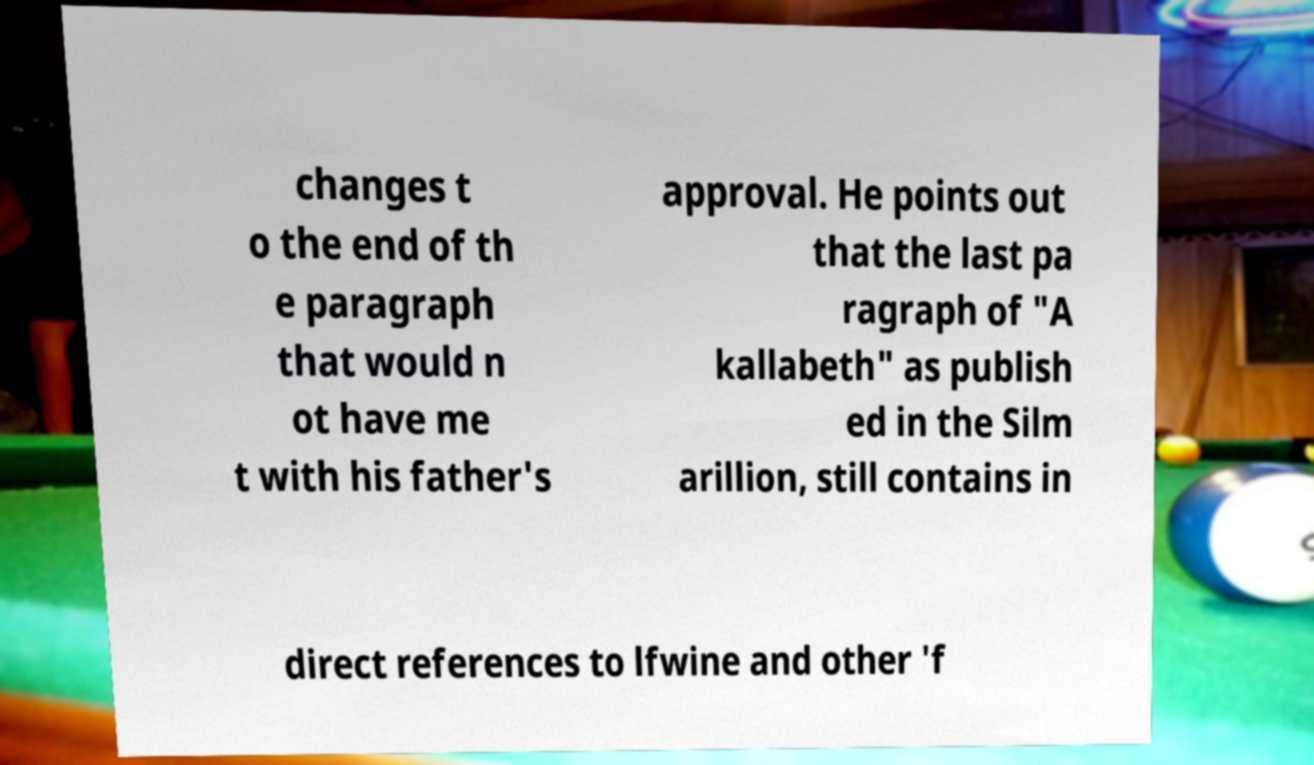There's text embedded in this image that I need extracted. Can you transcribe it verbatim? changes t o the end of th e paragraph that would n ot have me t with his father's approval. He points out that the last pa ragraph of "A kallabeth" as publish ed in the Silm arillion, still contains in direct references to lfwine and other 'f 